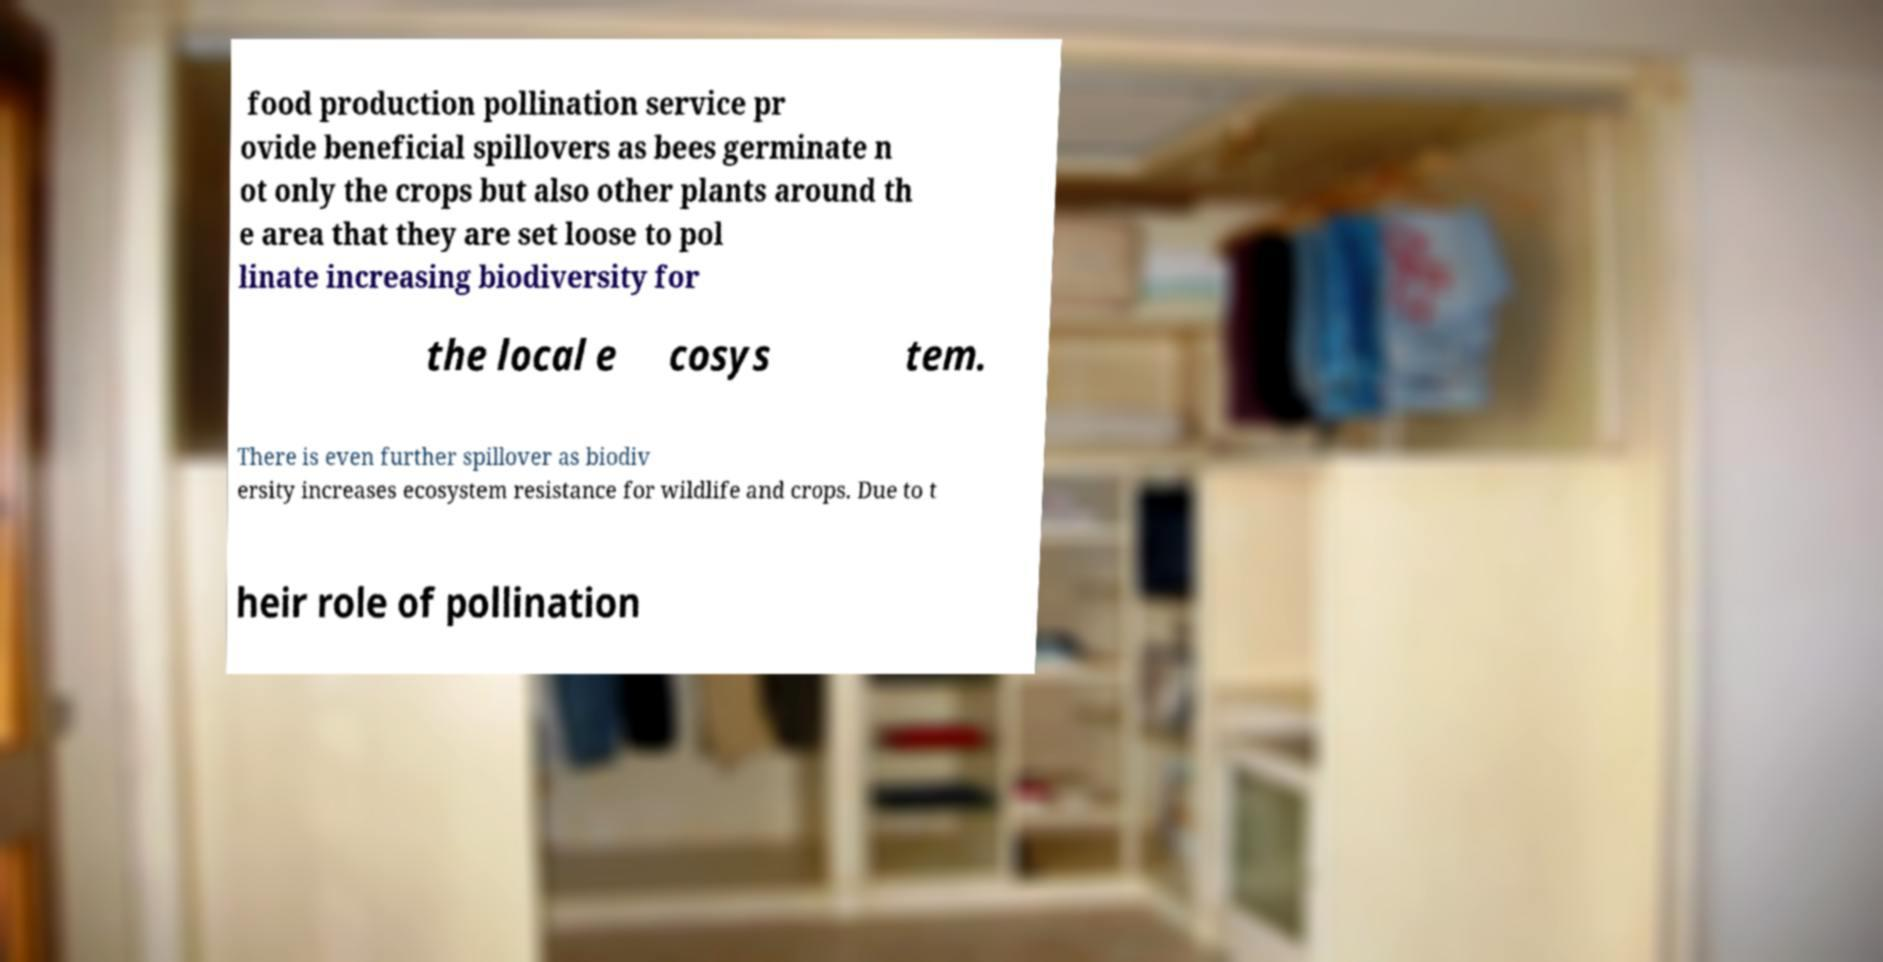Can you read and provide the text displayed in the image?This photo seems to have some interesting text. Can you extract and type it out for me? food production pollination service pr ovide beneficial spillovers as bees germinate n ot only the crops but also other plants around th e area that they are set loose to pol linate increasing biodiversity for the local e cosys tem. There is even further spillover as biodiv ersity increases ecosystem resistance for wildlife and crops. Due to t heir role of pollination 